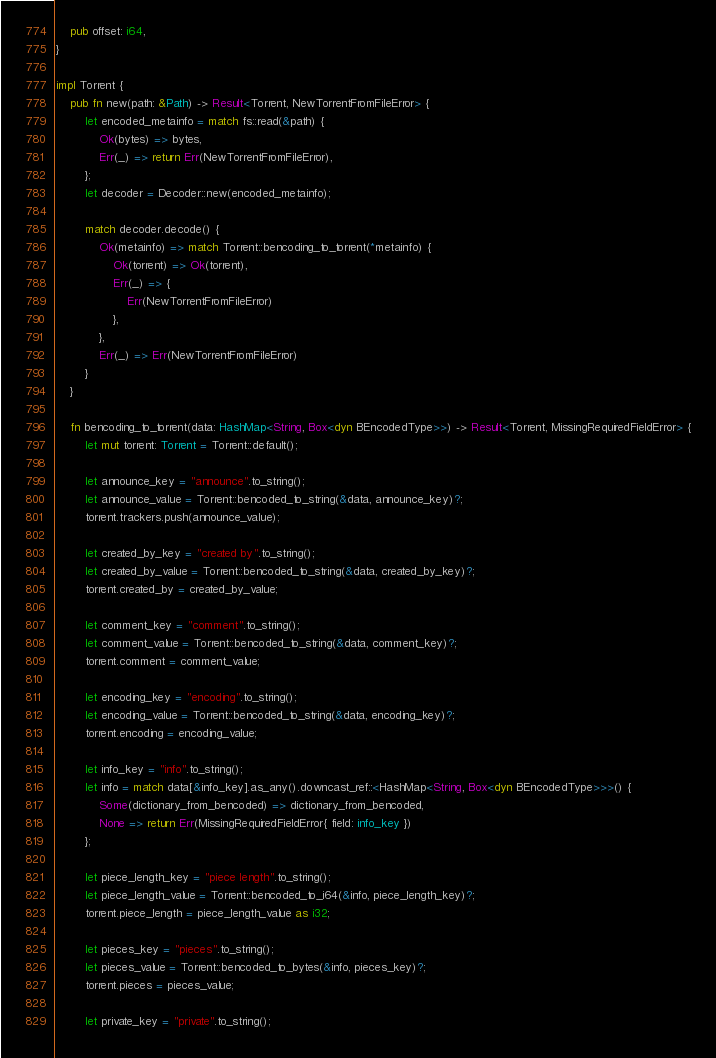<code> <loc_0><loc_0><loc_500><loc_500><_Rust_>    pub offset: i64,
}

impl Torrent {
    pub fn new(path: &Path) -> Result<Torrent, NewTorrentFromFileError> {
        let encoded_metainfo = match fs::read(&path) {
            Ok(bytes) => bytes,
            Err(_) => return Err(NewTorrentFromFileError),
        };
        let decoder = Decoder::new(encoded_metainfo);

        match decoder.decode() {
            Ok(metainfo) => match Torrent::bencoding_to_torrent(*metainfo) {
                Ok(torrent) => Ok(torrent),
                Err(_) => {
                    Err(NewTorrentFromFileError)
                },
            },
            Err(_) => Err(NewTorrentFromFileError)
        }
    }
    
    fn bencoding_to_torrent(data: HashMap<String, Box<dyn BEncodedType>>) -> Result<Torrent, MissingRequiredFieldError> {
        let mut torrent: Torrent = Torrent::default();
        
        let announce_key = "announce".to_string();
        let announce_value = Torrent::bencoded_to_string(&data, announce_key)?;
        torrent.trackers.push(announce_value);

        let created_by_key = "created by".to_string();
        let created_by_value = Torrent::bencoded_to_string(&data, created_by_key)?;
        torrent.created_by = created_by_value;
        
        let comment_key = "comment".to_string();
        let comment_value = Torrent::bencoded_to_string(&data, comment_key)?;
        torrent.comment = comment_value;
        
        let encoding_key = "encoding".to_string();
        let encoding_value = Torrent::bencoded_to_string(&data, encoding_key)?;
        torrent.encoding = encoding_value;
        
        let info_key = "info".to_string();
        let info = match data[&info_key].as_any().downcast_ref::<HashMap<String, Box<dyn BEncodedType>>>() {
            Some(dictionary_from_bencoded) => dictionary_from_bencoded,
            None => return Err(MissingRequiredFieldError{ field: info_key })
        };

        let piece_length_key = "piece length".to_string();
        let piece_length_value = Torrent::bencoded_to_i64(&info, piece_length_key)?;
        torrent.piece_length = piece_length_value as i32;

        let pieces_key = "pieces".to_string();
        let pieces_value = Torrent::bencoded_to_bytes(&info, pieces_key)?;
        torrent.pieces = pieces_value;

        let private_key = "private".to_string();</code> 